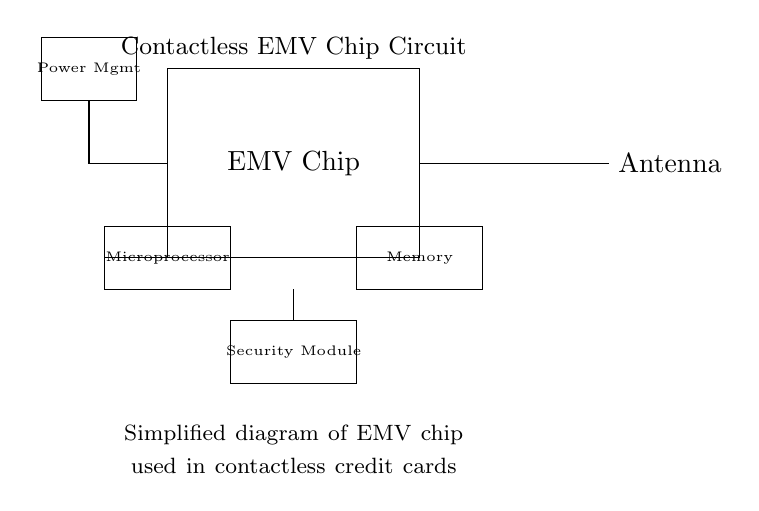What is the main component of the circuit? The main component is the EMV chip, which is central to the operation of the contactless credit card system and is displayed prominently in the diagram.
Answer: EMV chip What does the rectangle labeled "Power Mgmt" represent? The rectangle labeled "Power Mgmt" indicates the power management module, which is responsible for regulating and supplying power to the other components in the circuit.
Answer: Power management How many main modules are shown in the circuit diagram? There are four main modules shown: the EMV chip, Power Management, Security Module, and Microprocessor, plus the Memory and Antenna. Counting those, we identify the main parts involved in processing and security.
Answer: Four Which component connects the EMV chip and the Memory? The Microprocessor connects the EMV chip to the Memory module. The connection can be traced through the direct line from the EMV chip to the Microprocessor and then to the Memory.
Answer: Microprocessor What is the purpose of the Antenna in this circuit? The Antenna serves as the interface for contactless communication, enabling the credit card to interact wirelessly with payment terminals. This function is vital for the operation of contactless transactions.
Answer: Communication How does power flow from the Power Management to the EMV chip? Power flows from the Power Management module through a direct connection indicated in the diagram, illustrating that the EMV chip receives its operational power directly from the Power Management component.
Answer: Direct connection 